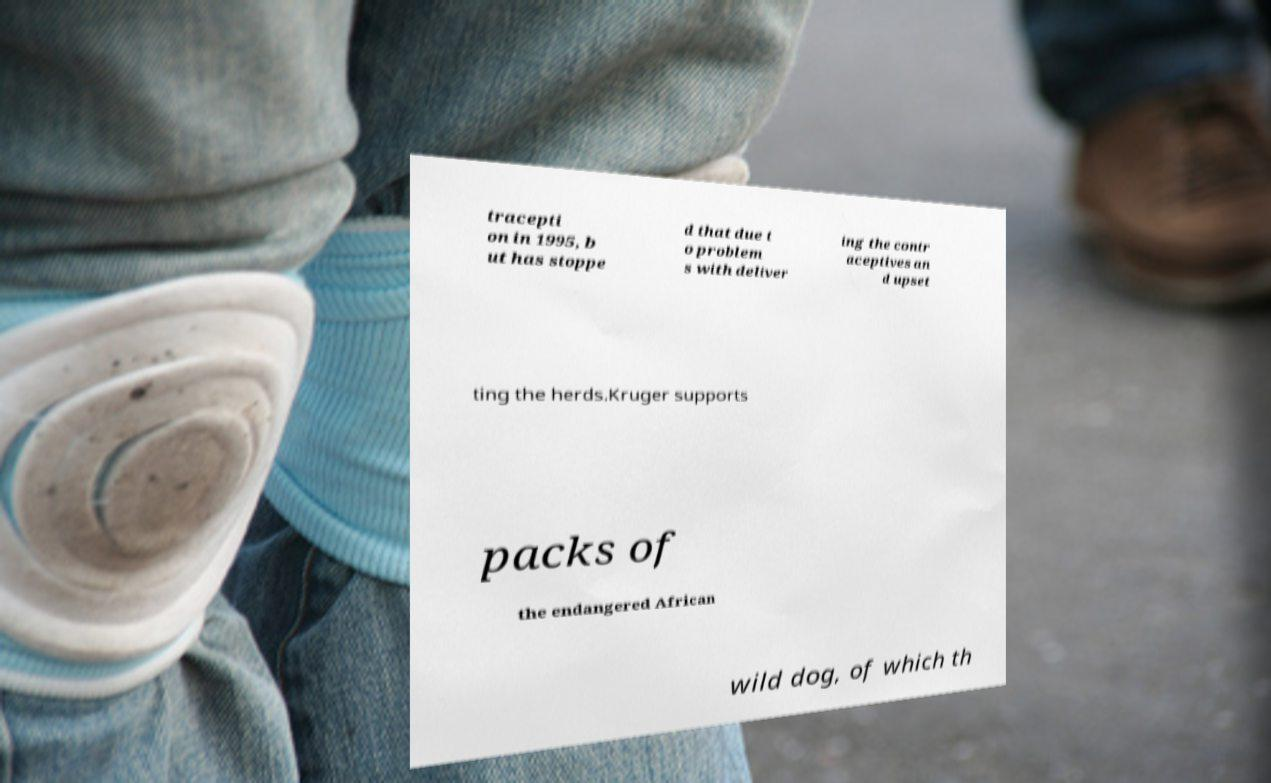There's text embedded in this image that I need extracted. Can you transcribe it verbatim? tracepti on in 1995, b ut has stoppe d that due t o problem s with deliver ing the contr aceptives an d upset ting the herds.Kruger supports packs of the endangered African wild dog, of which th 